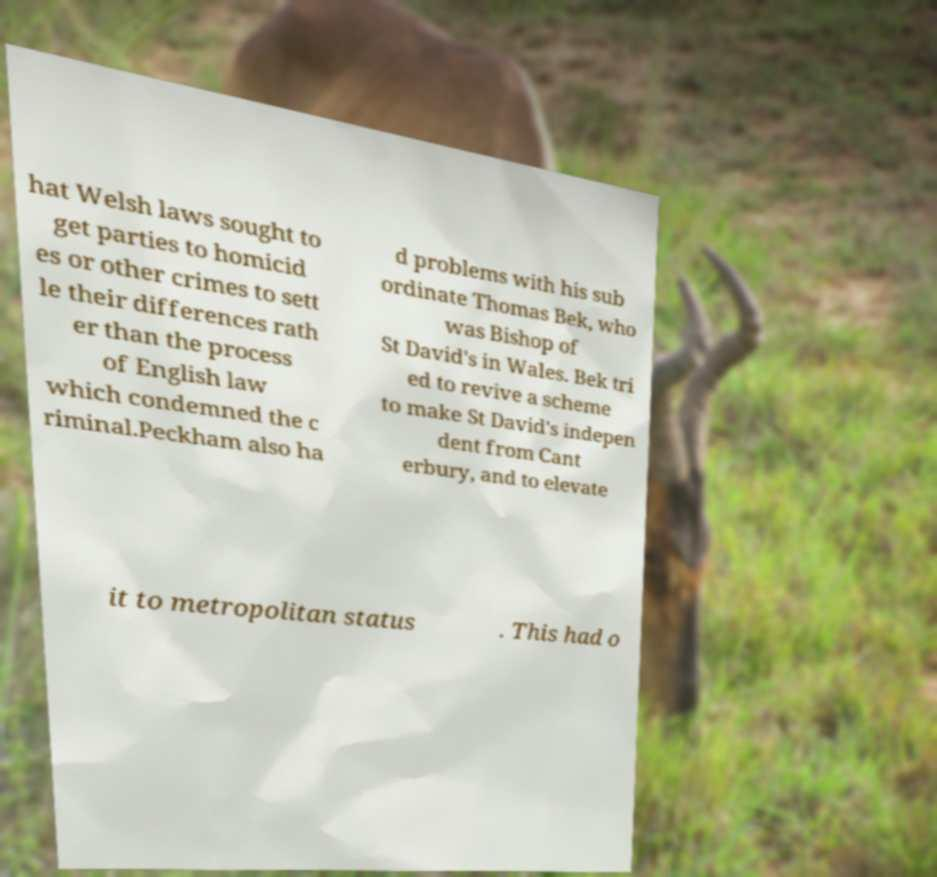Could you assist in decoding the text presented in this image and type it out clearly? hat Welsh laws sought to get parties to homicid es or other crimes to sett le their differences rath er than the process of English law which condemned the c riminal.Peckham also ha d problems with his sub ordinate Thomas Bek, who was Bishop of St David's in Wales. Bek tri ed to revive a scheme to make St David's indepen dent from Cant erbury, and to elevate it to metropolitan status . This had o 